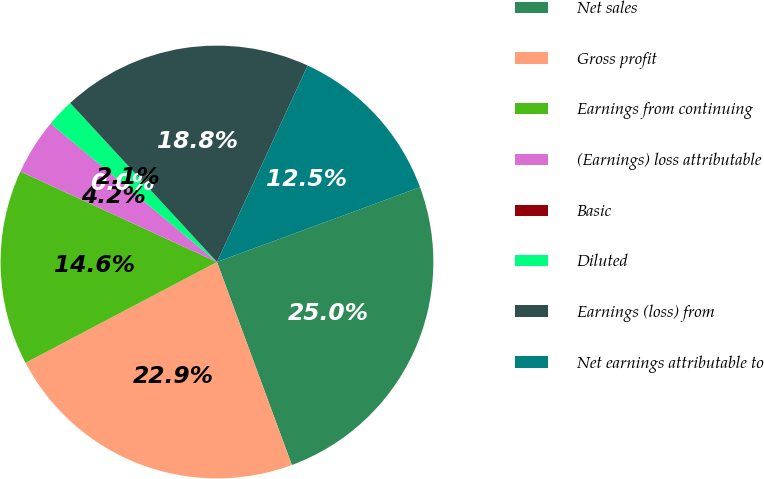Convert chart. <chart><loc_0><loc_0><loc_500><loc_500><pie_chart><fcel>Net sales<fcel>Gross profit<fcel>Earnings from continuing<fcel>(Earnings) loss attributable<fcel>Basic<fcel>Diluted<fcel>Earnings (loss) from<fcel>Net earnings attributable to<nl><fcel>24.99%<fcel>22.91%<fcel>14.58%<fcel>4.17%<fcel>0.01%<fcel>2.09%<fcel>18.75%<fcel>12.5%<nl></chart> 